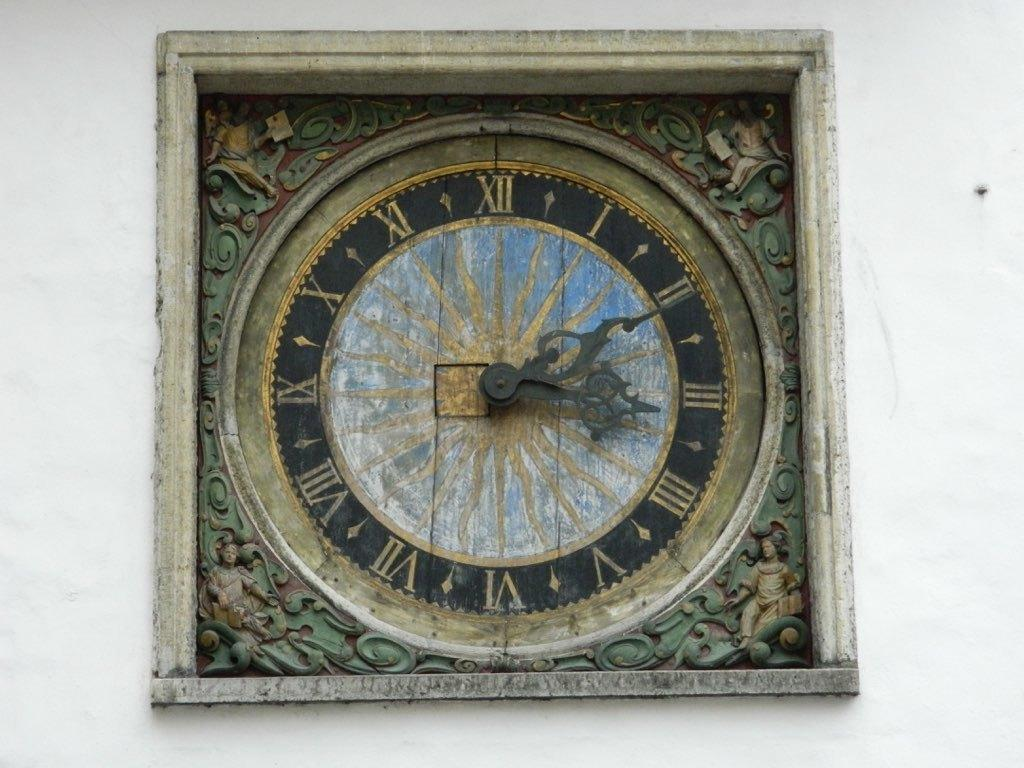<image>
Share a concise interpretation of the image provided. An old inset clock shows the time is eleven minutes after three. 